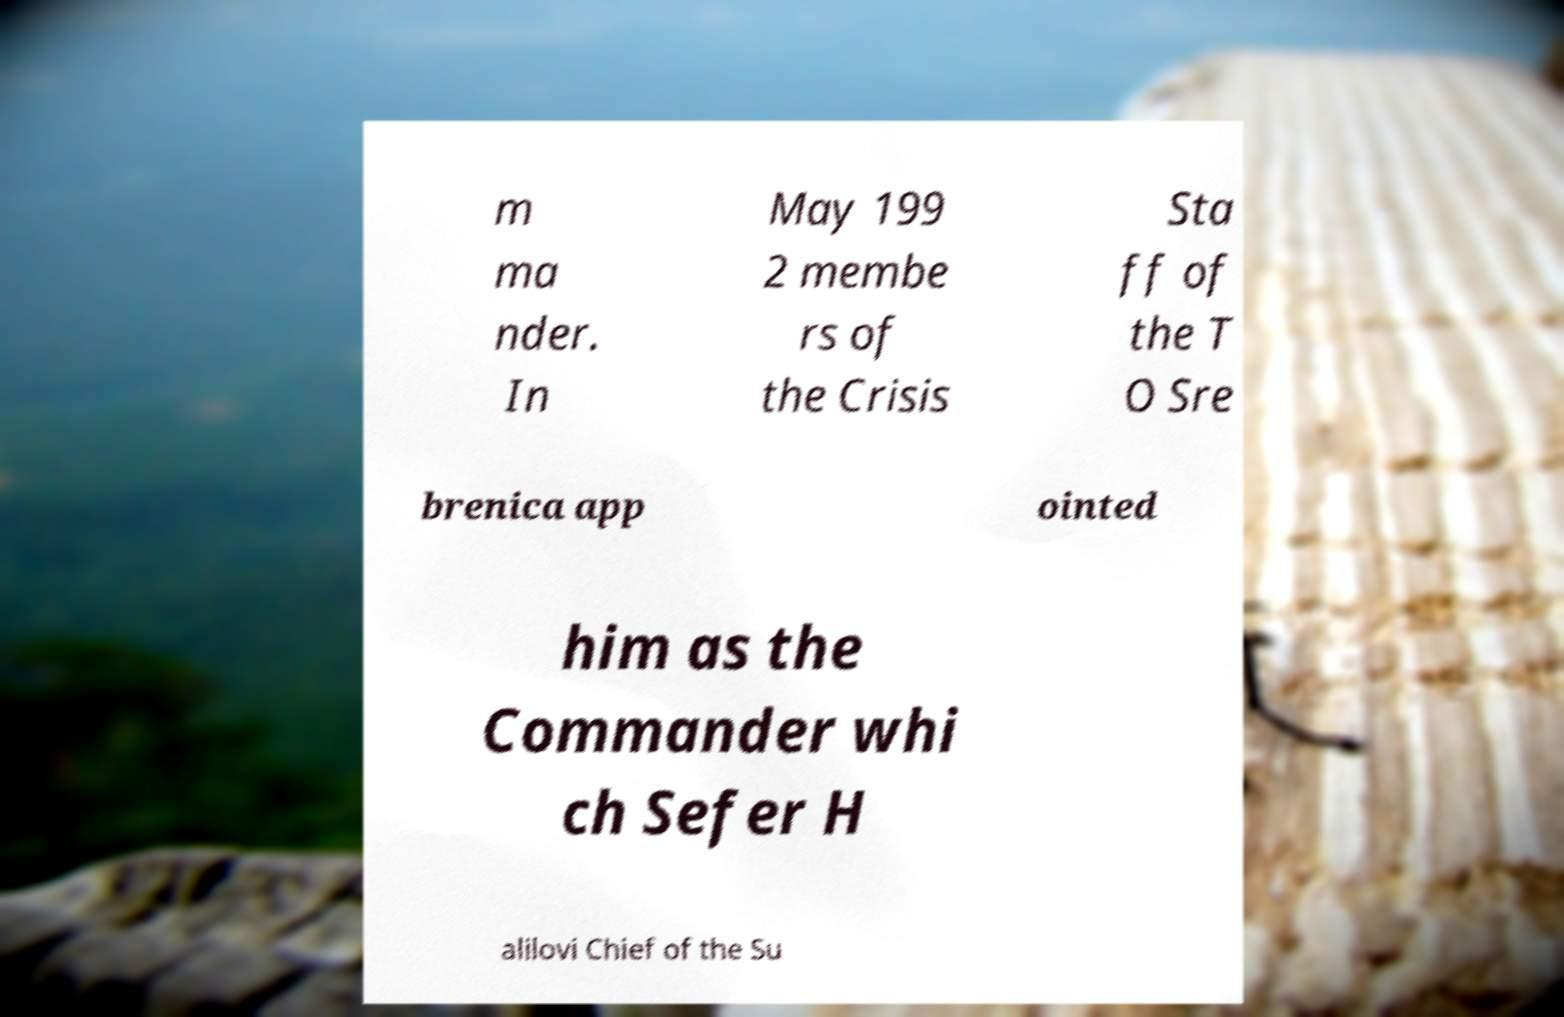Please read and relay the text visible in this image. What does it say? m ma nder. In May 199 2 membe rs of the Crisis Sta ff of the T O Sre brenica app ointed him as the Commander whi ch Sefer H alilovi Chief of the Su 